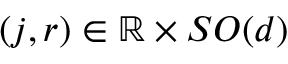<formula> <loc_0><loc_0><loc_500><loc_500>( j , r ) \in { \mathbb { R } } \times S O ( d )</formula> 